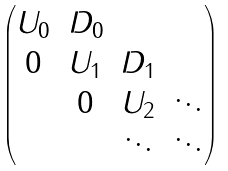<formula> <loc_0><loc_0><loc_500><loc_500>\begin{pmatrix} { U } _ { 0 } & { D } _ { 0 } & & \\ { 0 } & U _ { 1 } & { D } _ { 1 } & \\ & 0 & { U } _ { 2 } & \ddots \\ & & \ddots & \ddots \\ \end{pmatrix}</formula> 